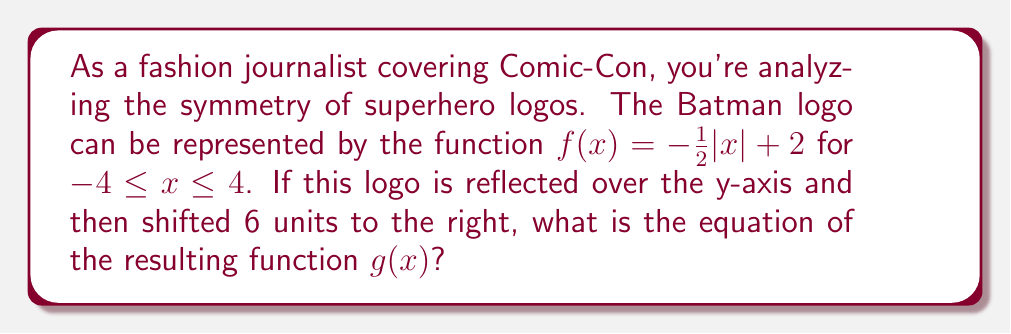Can you answer this question? Let's approach this step-by-step:

1) First, we need to reflect $f(x)$ over the y-axis. This is done by replacing $x$ with $-x$ in the original function:

   $f(-x) = -\frac{1}{2}|-x| + 2$

2) Since the absolute value of a negative number is the same as the absolute value of its positive counterpart, we can simplify this to:

   $f(-x) = -\frac{1}{2}|x| + 2$

3) Now, we need to shift this reflected function 6 units to the right. To shift a function to the right, we replace $x$ with $(x-6)$:

   $g(x) = -\frac{1}{2}|x-6| + 2$

4) This is our final function $g(x)$, which represents the Batman logo reflected over the y-axis and then shifted 6 units to the right.

[asy]
import graph;
size(200,200);
real f(real x) {return -0.5*abs(x) + 2;}
real g(real x) {return -0.5*abs(x-6) + 2;}
draw(graph(f,-4,4),blue);
draw(graph(g,2,10),red);
xaxis("x");
yaxis("y");
label("f(x)",(-2,1),blue);
label("g(x)",(8,1),red);
[/asy]
Answer: $g(x) = -\frac{1}{2}|x-6| + 2$ 